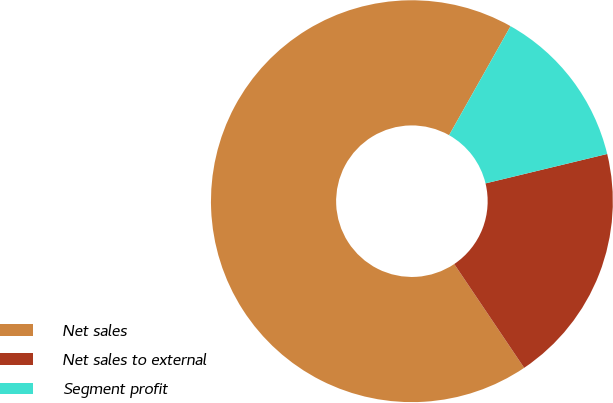Convert chart. <chart><loc_0><loc_0><loc_500><loc_500><pie_chart><fcel>Net sales<fcel>Net sales to external<fcel>Segment profit<nl><fcel>67.6%<fcel>19.34%<fcel>13.05%<nl></chart> 